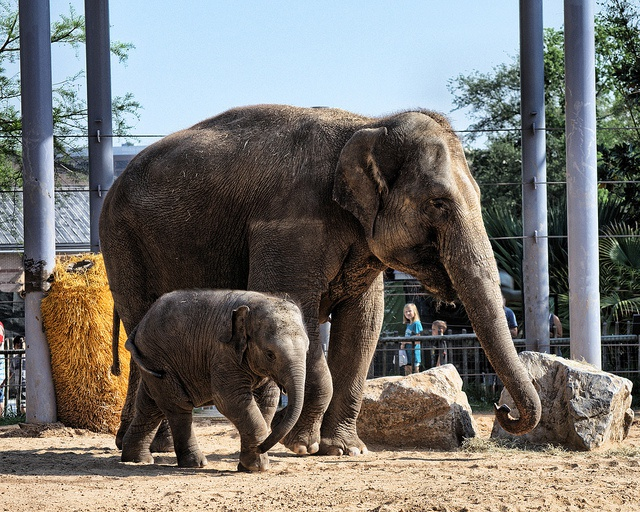Describe the objects in this image and their specific colors. I can see elephant in lightblue, black, gray, and maroon tones, elephant in lightblue, black, gray, and darkgray tones, people in lightblue, black, gray, darkgray, and blue tones, people in lightblue, black, gray, darkgray, and lightgray tones, and people in lightblue, black, gray, darkgray, and lightgray tones in this image. 